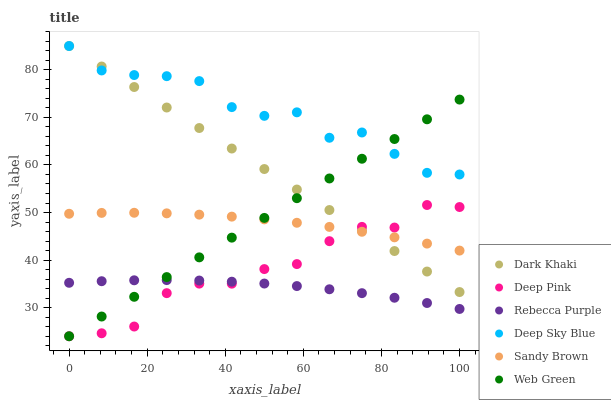Does Rebecca Purple have the minimum area under the curve?
Answer yes or no. Yes. Does Deep Sky Blue have the maximum area under the curve?
Answer yes or no. Yes. Does Web Green have the minimum area under the curve?
Answer yes or no. No. Does Web Green have the maximum area under the curve?
Answer yes or no. No. Is Dark Khaki the smoothest?
Answer yes or no. Yes. Is Deep Sky Blue the roughest?
Answer yes or no. Yes. Is Web Green the smoothest?
Answer yes or no. No. Is Web Green the roughest?
Answer yes or no. No. Does Deep Pink have the lowest value?
Answer yes or no. Yes. Does Dark Khaki have the lowest value?
Answer yes or no. No. Does Deep Sky Blue have the highest value?
Answer yes or no. Yes. Does Web Green have the highest value?
Answer yes or no. No. Is Sandy Brown less than Deep Sky Blue?
Answer yes or no. Yes. Is Deep Sky Blue greater than Deep Pink?
Answer yes or no. Yes. Does Deep Sky Blue intersect Web Green?
Answer yes or no. Yes. Is Deep Sky Blue less than Web Green?
Answer yes or no. No. Is Deep Sky Blue greater than Web Green?
Answer yes or no. No. Does Sandy Brown intersect Deep Sky Blue?
Answer yes or no. No. 